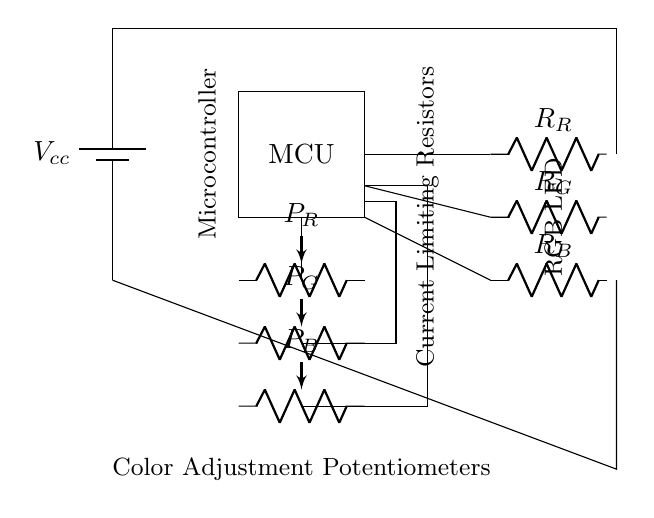What is the main function of the microcontroller in the circuit? The microcontroller controls the color and brightness of the RGB LED based on inputs from the potentiometers.
Answer: control RGB LED What type of potentiometers are used in this circuit? The circuit uses variable resistors (potentiometers) to adjust the resistance which controls the current flowing to each color of the RGB LED.
Answer: variable resistors How many resistors are present in the circuit? There are three current limiting resistors, one for each color of the RGB LED (red, green, and blue).
Answer: three What does the color adjustment potentiometer do? It allows the user to adjust the brightness of each color in the RGB LED by modifying the voltage across the LED.
Answer: adjust brightness Which components form the RGB LED? The RGB LED consists of three separate LEDs: red, green, and blue.
Answer: three separate LEDs In what way does the potentiometer affect the LED brightness? By changing the resistance in the circuit, the potentiometers control the amount of current flowing through each LED, thus adjusting their brightness.
Answer: controls current 